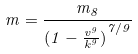Convert formula to latex. <formula><loc_0><loc_0><loc_500><loc_500>m = \frac { m _ { 8 } } { ( { 1 - \frac { v ^ { 9 } } { k ^ { 9 } } ) } ^ { 7 / 9 } }</formula> 